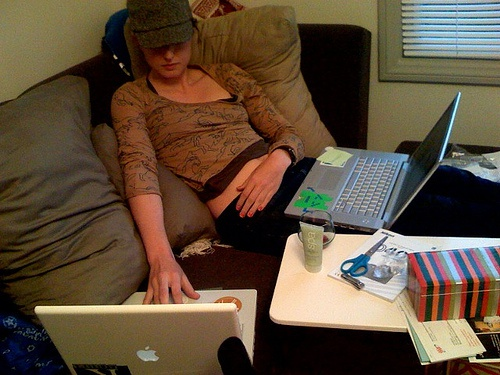Describe the objects in this image and their specific colors. I can see couch in olive, black, maroon, and gray tones, people in olive, black, maroon, and brown tones, laptop in olive, black, and gray tones, laptop in olive, gray, black, and darkgray tones, and book in olive, lightgray, darkgray, gray, and blue tones in this image. 